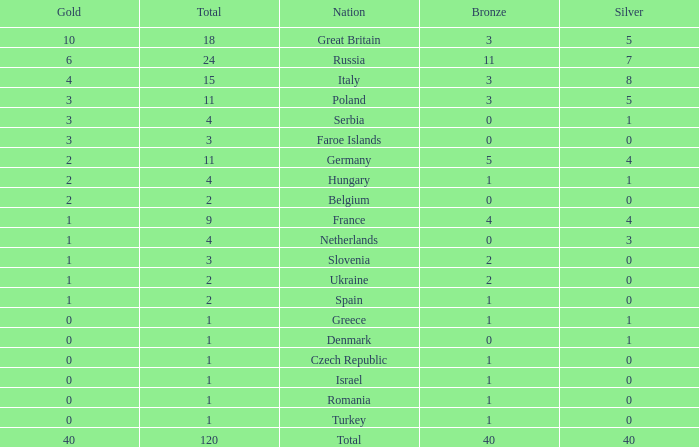What Nation has a Gold entry that is greater than 0, a Total that is greater than 2, a Silver entry that is larger than 1, and 0 Bronze? Netherlands. 